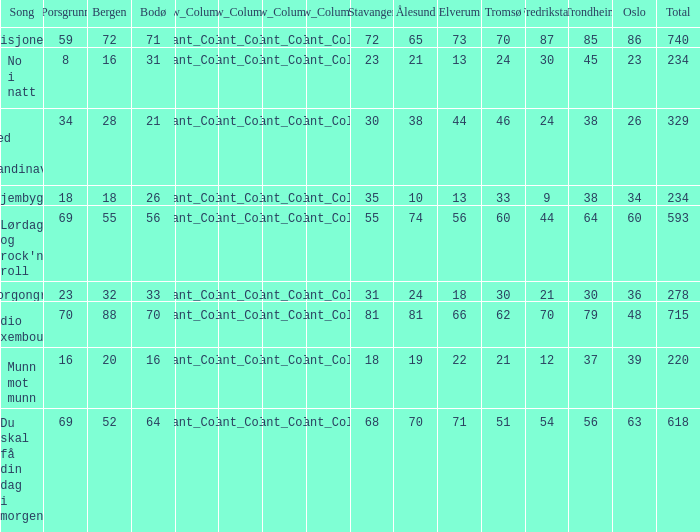When the total score is 740, what is tromso? 70.0. 